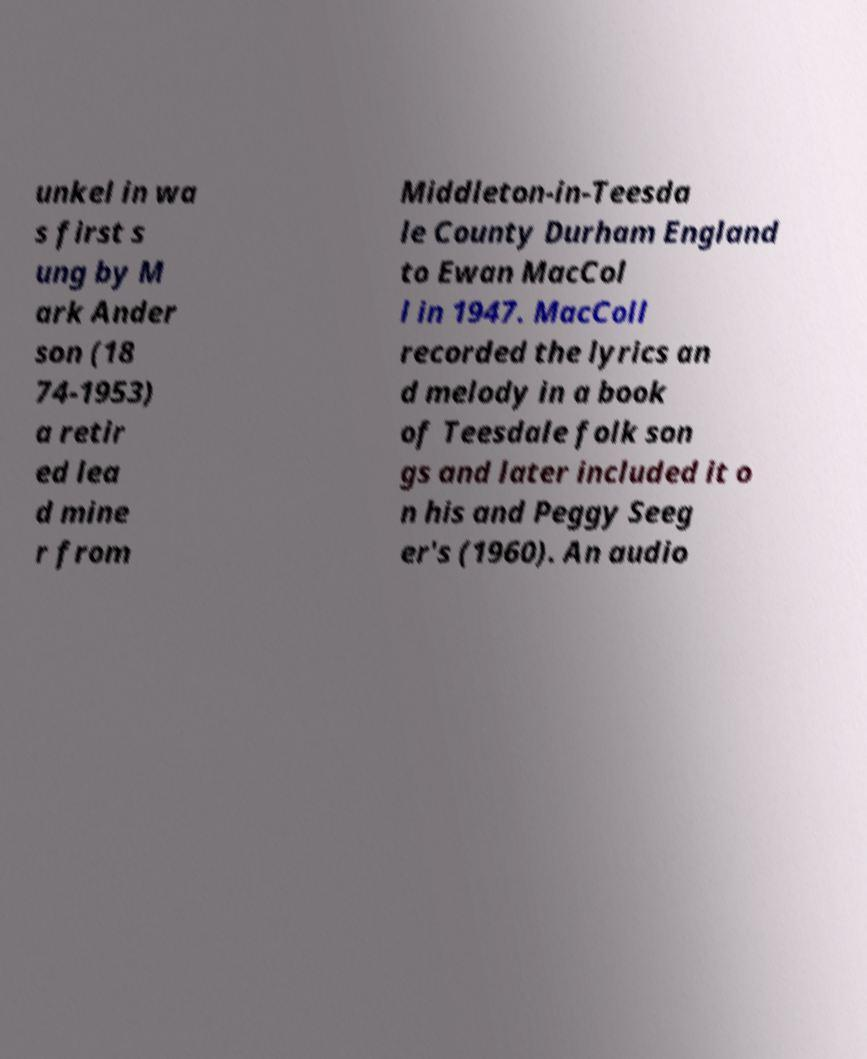Could you extract and type out the text from this image? unkel in wa s first s ung by M ark Ander son (18 74-1953) a retir ed lea d mine r from Middleton-in-Teesda le County Durham England to Ewan MacCol l in 1947. MacColl recorded the lyrics an d melody in a book of Teesdale folk son gs and later included it o n his and Peggy Seeg er's (1960). An audio 